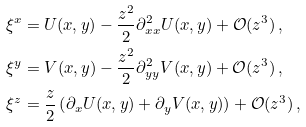Convert formula to latex. <formula><loc_0><loc_0><loc_500><loc_500>\xi ^ { x } & = U ( x , y ) - \frac { z ^ { 2 } } { 2 } \partial ^ { 2 } _ { x x } U ( x , y ) + \mathcal { O } ( z ^ { 3 } ) \, , \\ \xi ^ { y } & = V ( x , y ) - \frac { z ^ { 2 } } { 2 } \partial ^ { 2 } _ { y y } V ( x , y ) + \mathcal { O } ( z ^ { 3 } ) \, , \\ \xi ^ { z } & = \frac { z } { 2 } \left ( \partial _ { x } U ( x , y ) + \partial _ { y } V ( x , y ) \right ) + \mathcal { O } ( z ^ { 3 } ) \, ,</formula> 